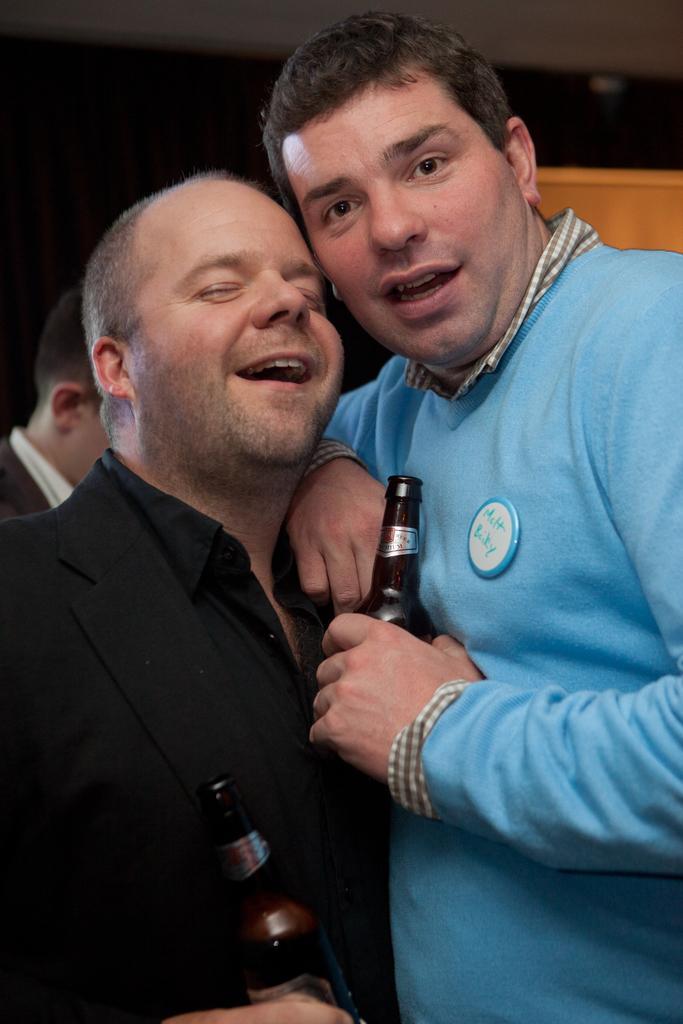Describe this image in one or two sentences. In this image, There are two people standing and they are holding the wine bottles which are in black color, In the background there is a yellow color box. 